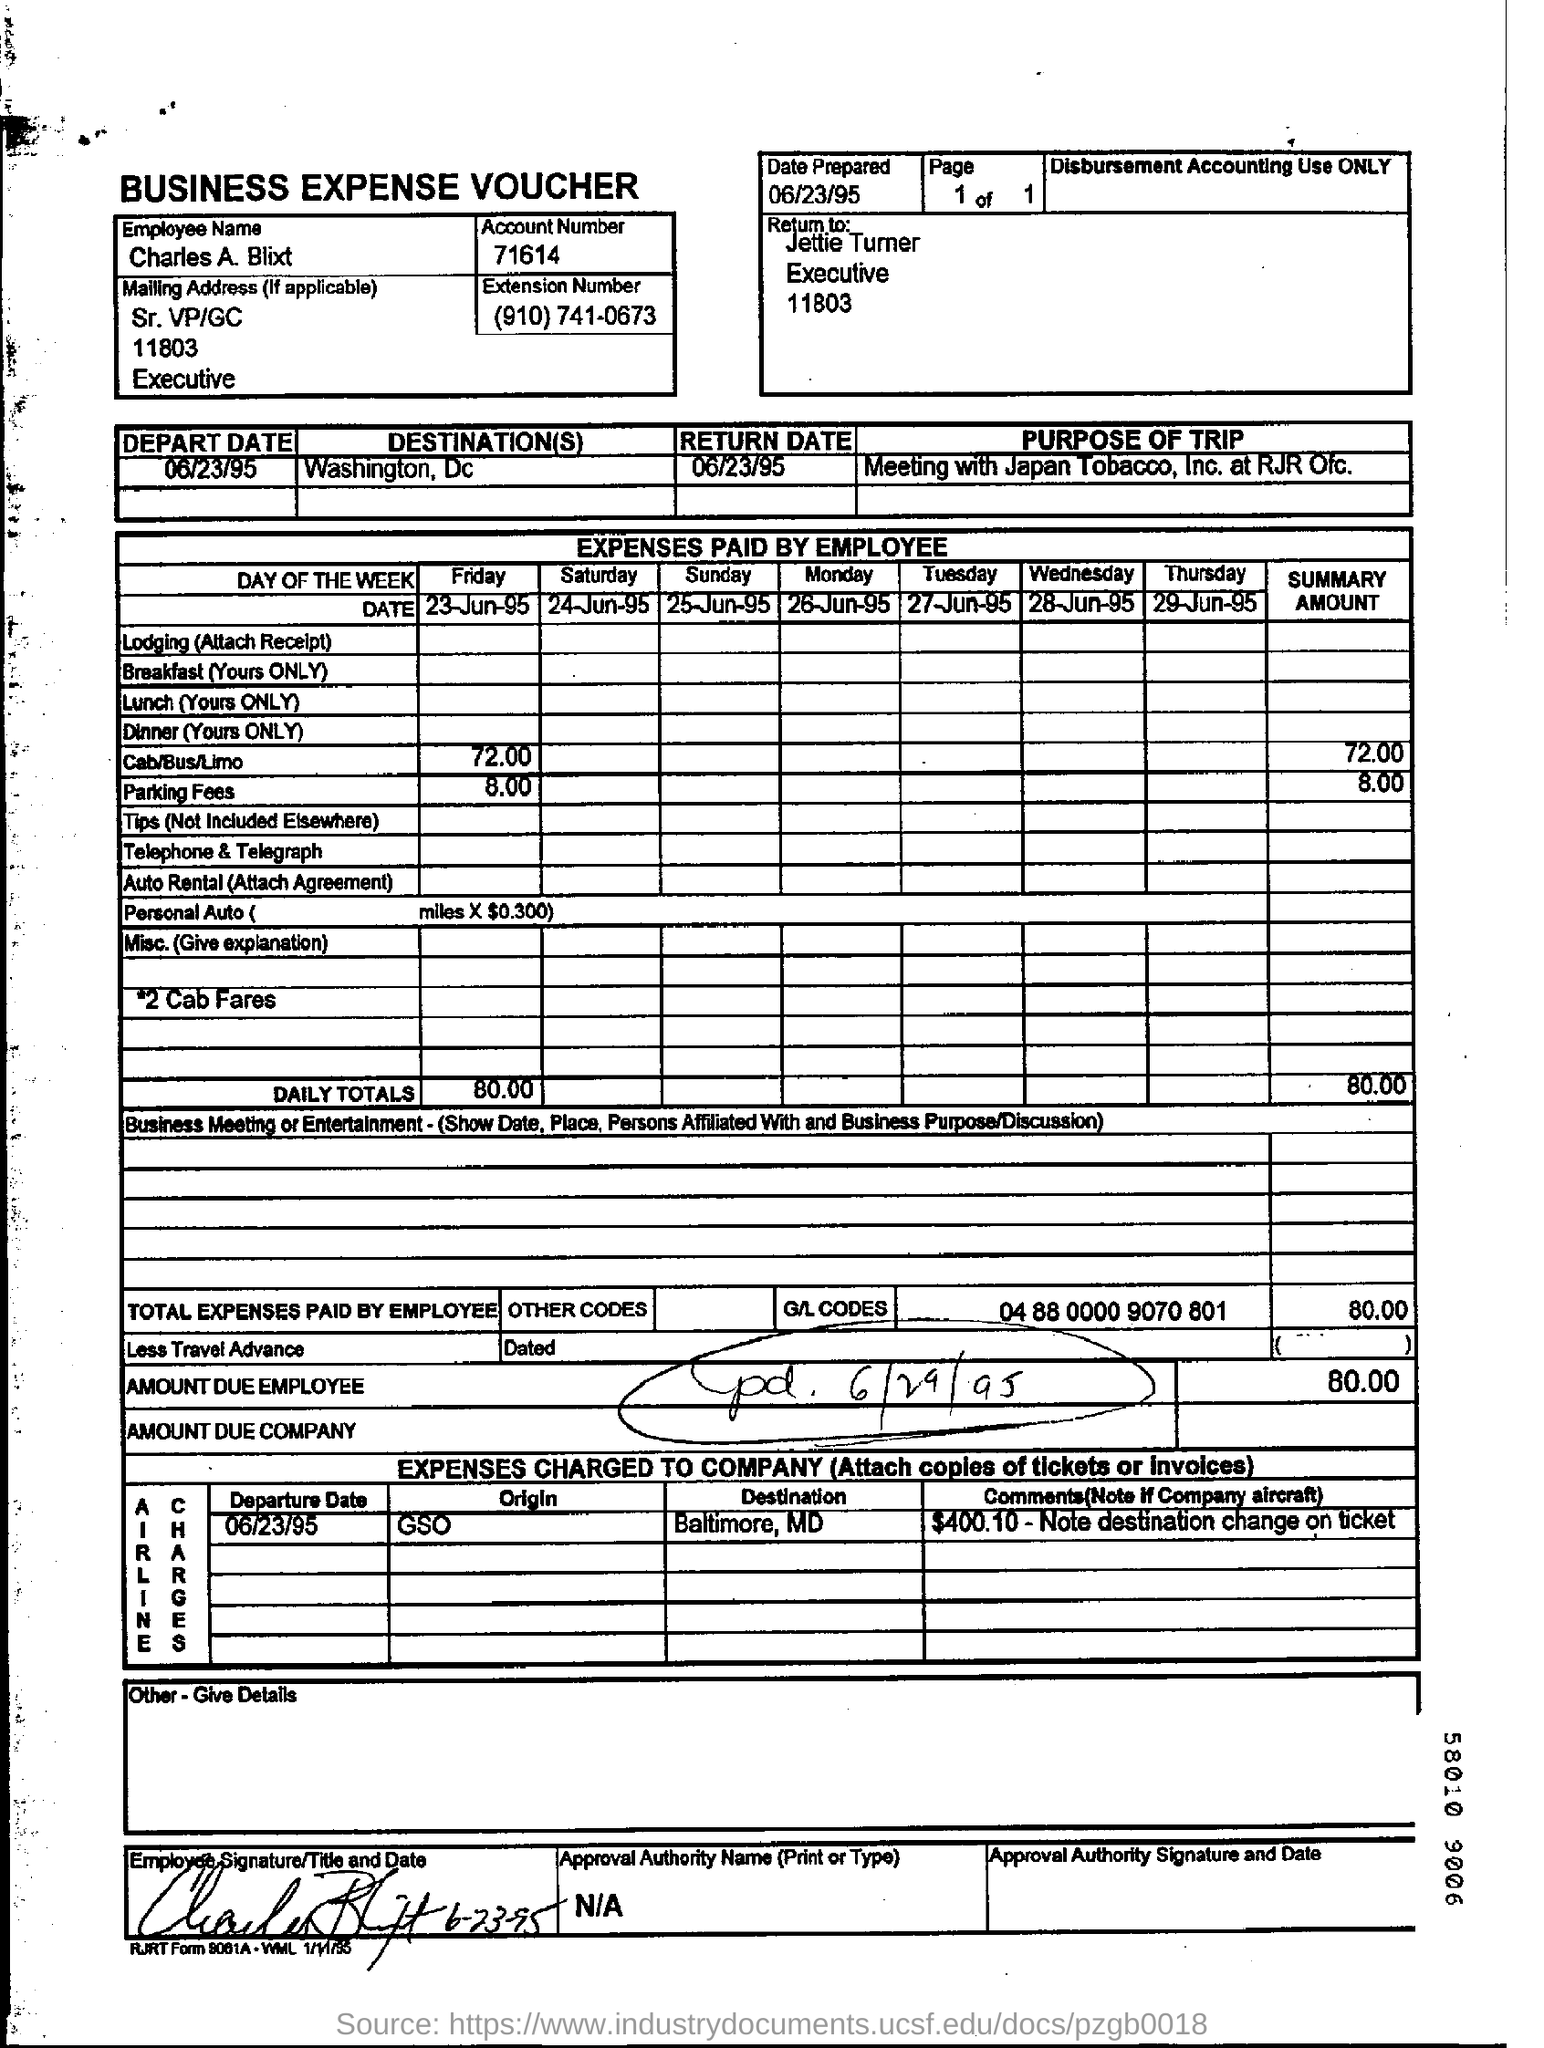What is the employee name mentioned in the business expense voucher?
Your answer should be very brief. Charles A. Blixt. What is the account number given in the business expense voucher?
Keep it short and to the point. 71614. On which date this business expense voucher is prepared?
Give a very brief answer. 06/23/95. What is the purpose of the trip mentioned in the voucher?
Ensure brevity in your answer.  Meeting with Japan tobacco , Inc at RJR ofc. What is the total expenses paid by the employee?
Make the answer very short. 80.00. How much amount does the employee paid for parking fees?
Give a very brief answer. 8:00. What is the employee name given in the voucher?
Your answer should be compact. Charles A. Blixt. How much is the amount in due by the employee?
Your response must be concise. 80.00. 